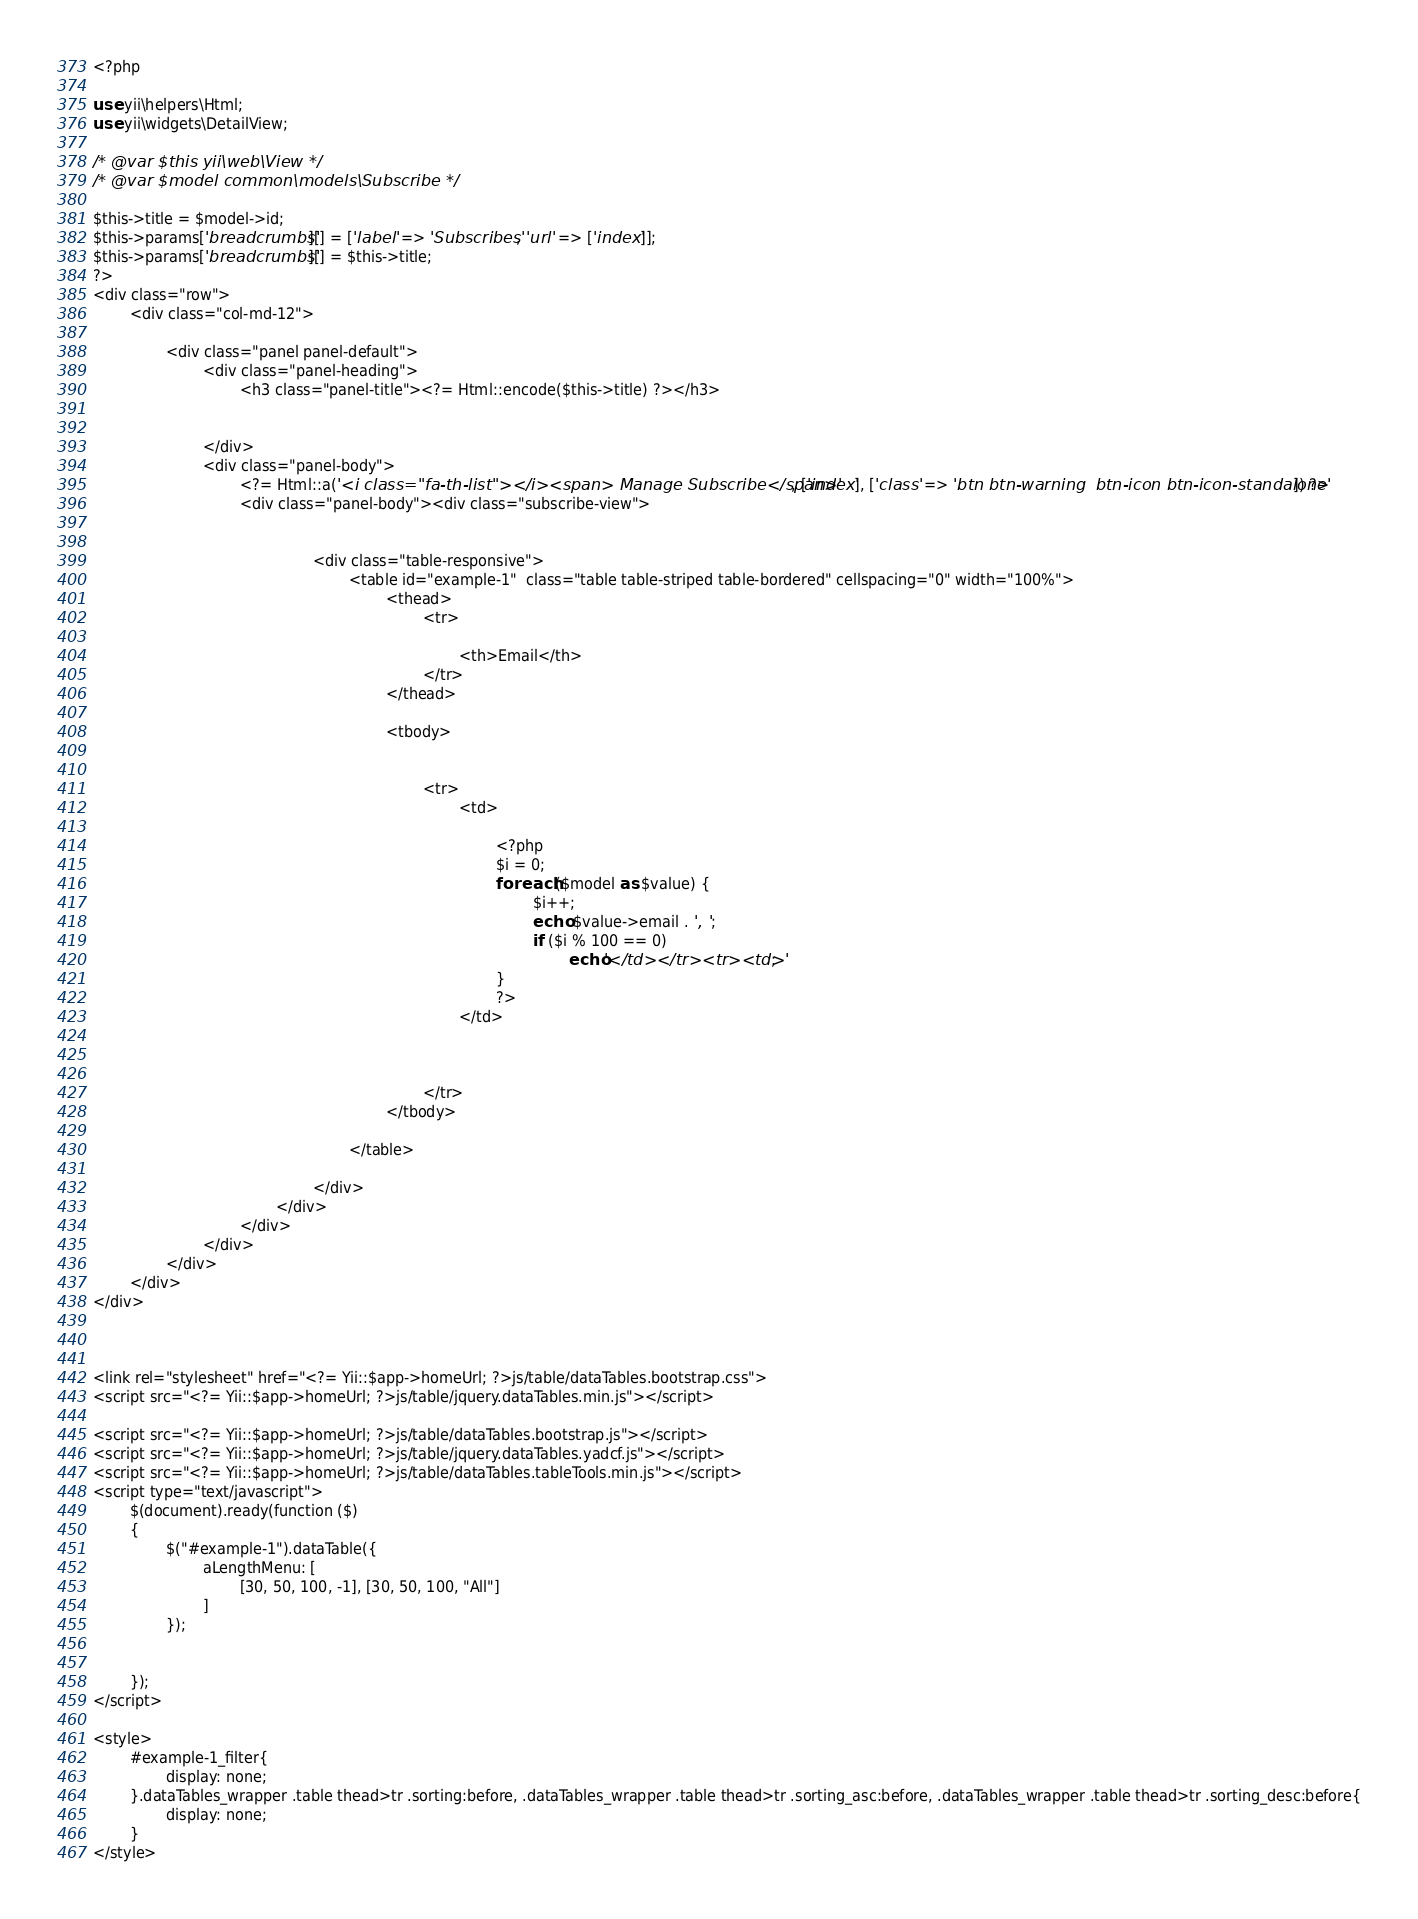<code> <loc_0><loc_0><loc_500><loc_500><_PHP_><?php

use yii\helpers\Html;
use yii\widgets\DetailView;

/* @var $this yii\web\View */
/* @var $model common\models\Subscribe */

$this->title = $model->id;
$this->params['breadcrumbs'][] = ['label' => 'Subscribes', 'url' => ['index']];
$this->params['breadcrumbs'][] = $this->title;
?>
<div class="row">
        <div class="col-md-12">

                <div class="panel panel-default">
                        <div class="panel-heading">
                                <h3 class="panel-title"><?= Html::encode($this->title) ?></h3>


                        </div>
                        <div class="panel-body">
                                <?= Html::a('<i class="fa-th-list"></i><span> Manage Subscribe</span>', ['index'], ['class' => 'btn btn-warning  btn-icon btn-icon-standalone']) ?>
                                <div class="panel-body"><div class="subscribe-view">


                                                <div class="table-responsive">
                                                        <table id="example-1"  class="table table-striped table-bordered" cellspacing="0" width="100%">
                                                                <thead>
                                                                        <tr>

                                                                                <th>Email</th>
                                                                        </tr>
                                                                </thead>

                                                                <tbody>


                                                                        <tr>
                                                                                <td>

                                                                                        <?php
                                                                                        $i = 0;
                                                                                        foreach ($model as $value) {
                                                                                                $i++;
                                                                                                echo $value->email . ', ';
                                                                                                if ($i % 100 == 0)
                                                                                                        echo'</td></tr><tr><td>';
                                                                                        }
                                                                                        ?>
                                                                                </td>



                                                                        </tr>
                                                                </tbody>

                                                        </table>

                                                </div>
                                        </div>
                                </div>
                        </div>
                </div>
        </div>
</div>



<link rel="stylesheet" href="<?= Yii::$app->homeUrl; ?>js/table/dataTables.bootstrap.css">
<script src="<?= Yii::$app->homeUrl; ?>js/table/jquery.dataTables.min.js"></script>

<script src="<?= Yii::$app->homeUrl; ?>js/table/dataTables.bootstrap.js"></script>
<script src="<?= Yii::$app->homeUrl; ?>js/table/jquery.dataTables.yadcf.js"></script>
<script src="<?= Yii::$app->homeUrl; ?>js/table/dataTables.tableTools.min.js"></script>
<script type="text/javascript">
        $(document).ready(function ($)
        {
                $("#example-1").dataTable({
                        aLengthMenu: [
                                [30, 50, 100, -1], [30, 50, 100, "All"]
                        ]
                });


        });
</script>

<style>
        #example-1_filter{
                display: none;
        }.dataTables_wrapper .table thead>tr .sorting:before, .dataTables_wrapper .table thead>tr .sorting_asc:before, .dataTables_wrapper .table thead>tr .sorting_desc:before{
                display: none;
        }
</style></code> 